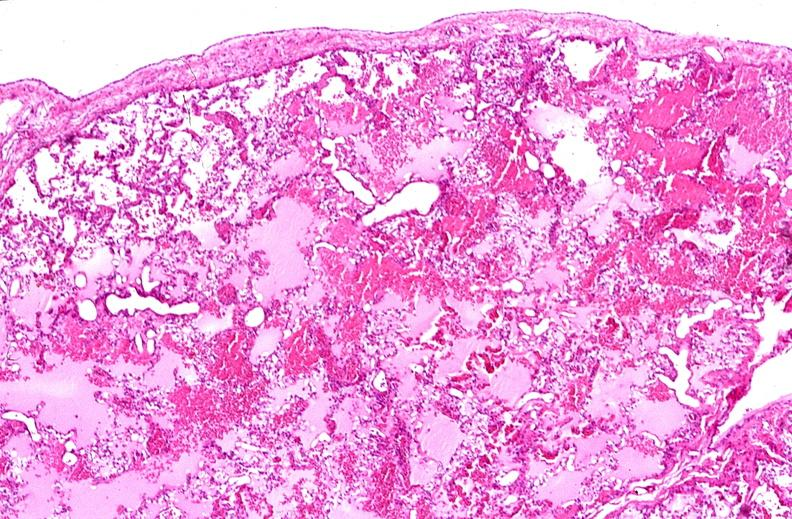s anaplastic carcinoma with desmoplasia large myofibroblastic cell present?
Answer the question using a single word or phrase. No 